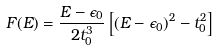Convert formula to latex. <formula><loc_0><loc_0><loc_500><loc_500>F ( E ) = \frac { E - \epsilon _ { 0 } } { 2 t _ { 0 } ^ { 3 } } \left [ ( E - \epsilon _ { 0 } ) ^ { 2 } - t _ { 0 } ^ { 2 } \right ]</formula> 